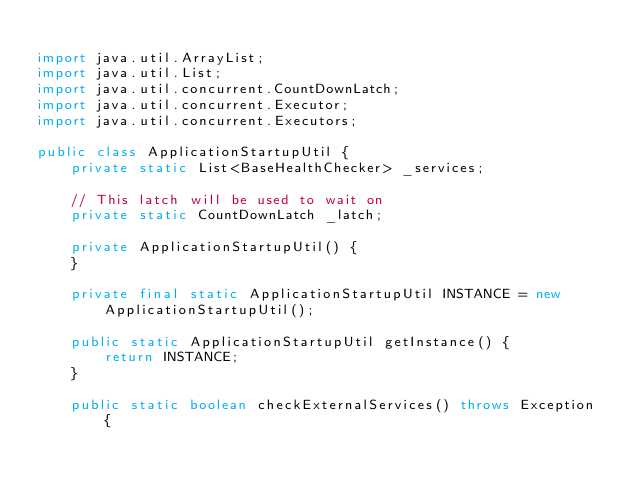Convert code to text. <code><loc_0><loc_0><loc_500><loc_500><_Java_>
import java.util.ArrayList;
import java.util.List;
import java.util.concurrent.CountDownLatch;
import java.util.concurrent.Executor;
import java.util.concurrent.Executors;

public class ApplicationStartupUtil {
    private static List<BaseHealthChecker> _services;

    // This latch will be used to wait on
    private static CountDownLatch _latch;

    private ApplicationStartupUtil() {
    }

    private final static ApplicationStartupUtil INSTANCE = new ApplicationStartupUtil();

    public static ApplicationStartupUtil getInstance() {
        return INSTANCE;
    }

    public static boolean checkExternalServices() throws Exception {</code> 